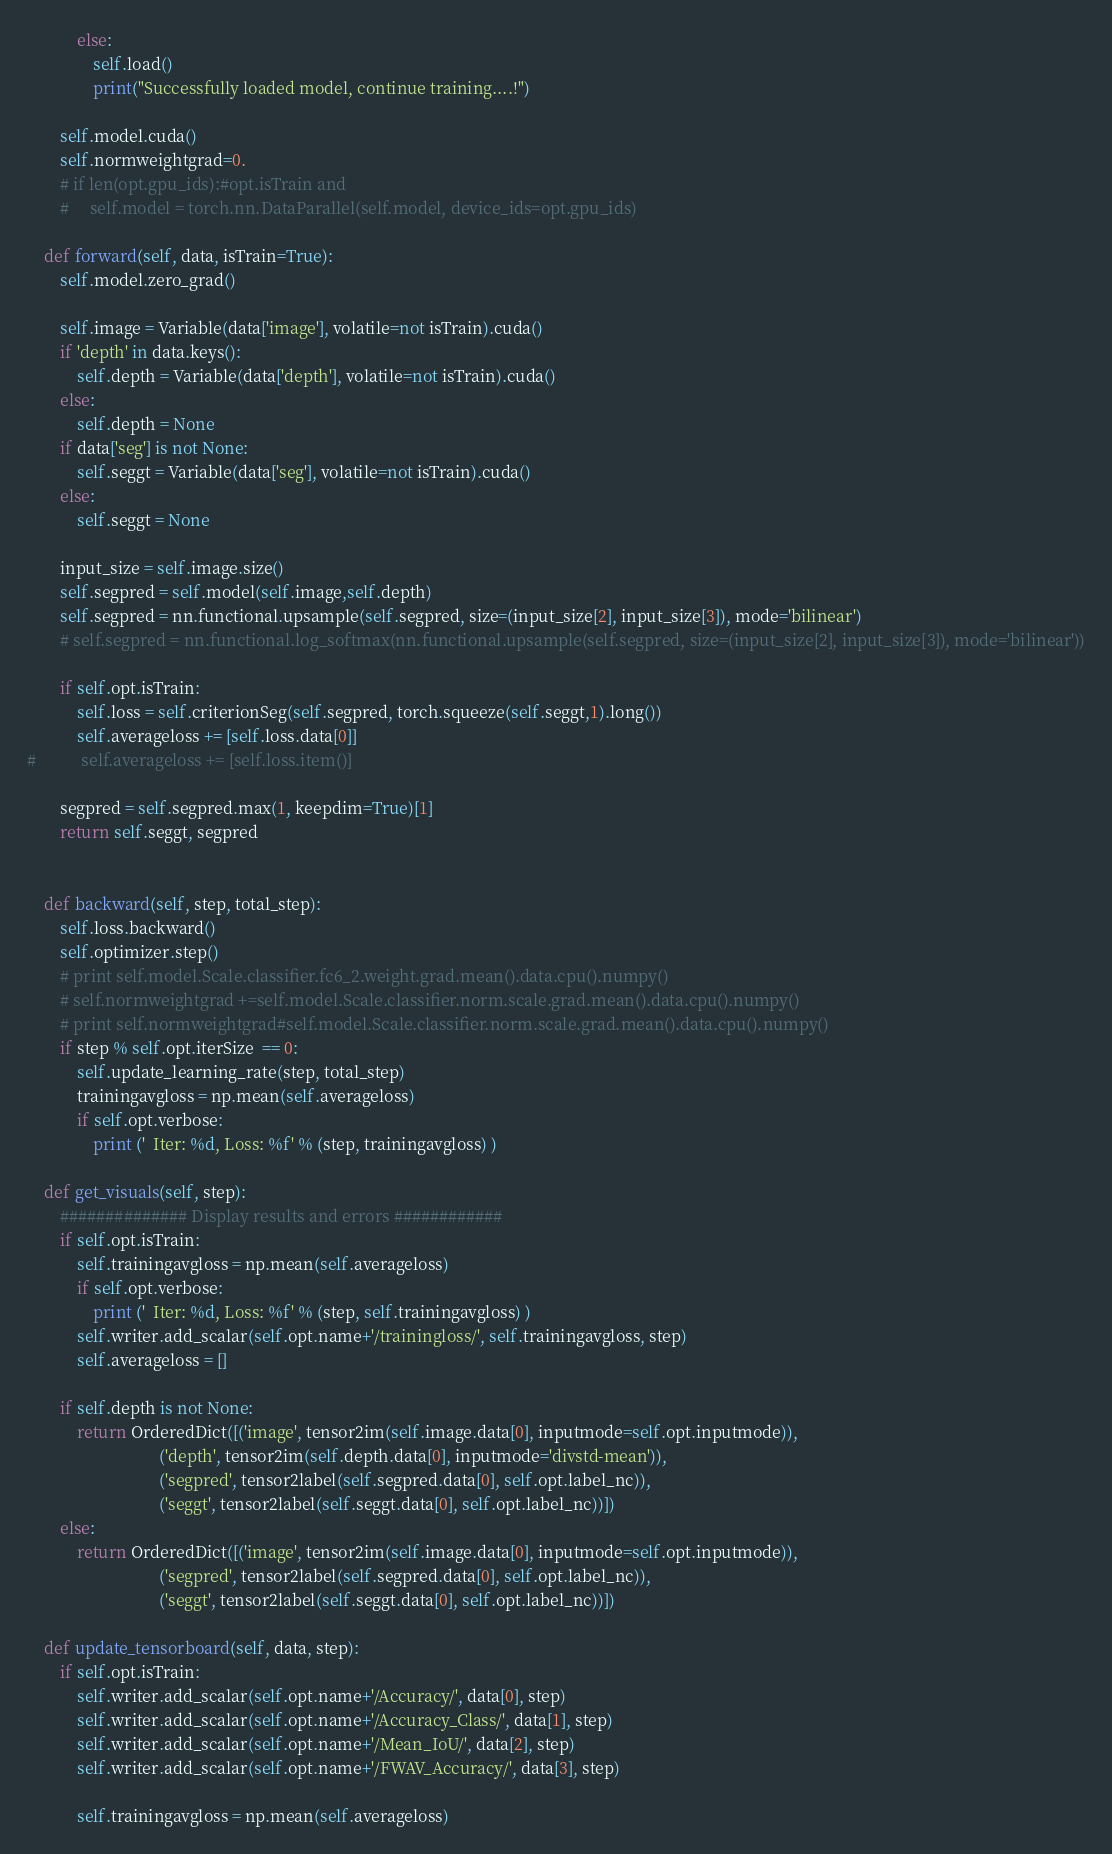<code> <loc_0><loc_0><loc_500><loc_500><_Python_>            else:
                self.load()
                print("Successfully loaded model, continue training....!")

        self.model.cuda()
        self.normweightgrad=0.
        # if len(opt.gpu_ids):#opt.isTrain and
        #     self.model = torch.nn.DataParallel(self.model, device_ids=opt.gpu_ids)

    def forward(self, data, isTrain=True):
        self.model.zero_grad()

        self.image = Variable(data['image'], volatile=not isTrain).cuda()
        if 'depth' in data.keys():
            self.depth = Variable(data['depth'], volatile=not isTrain).cuda()
        else:
            self.depth = None
        if data['seg'] is not None:
            self.seggt = Variable(data['seg'], volatile=not isTrain).cuda()
        else:
            self.seggt = None

        input_size = self.image.size()
        self.segpred = self.model(self.image,self.depth)
        self.segpred = nn.functional.upsample(self.segpred, size=(input_size[2], input_size[3]), mode='bilinear')
        # self.segpred = nn.functional.log_softmax(nn.functional.upsample(self.segpred, size=(input_size[2], input_size[3]), mode='bilinear'))

        if self.opt.isTrain:
            self.loss = self.criterionSeg(self.segpred, torch.squeeze(self.seggt,1).long())
            self.averageloss += [self.loss.data[0]]
#           self.averageloss += [self.loss.item()]
        
        segpred = self.segpred.max(1, keepdim=True)[1]
        return self.seggt, segpred


    def backward(self, step, total_step):
        self.loss.backward()
        self.optimizer.step()
        # print self.model.Scale.classifier.fc6_2.weight.grad.mean().data.cpu().numpy()
        # self.normweightgrad +=self.model.Scale.classifier.norm.scale.grad.mean().data.cpu().numpy()
        # print self.normweightgrad#self.model.Scale.classifier.norm.scale.grad.mean().data.cpu().numpy()
        if step % self.opt.iterSize  == 0:
            self.update_learning_rate(step, total_step)
            trainingavgloss = np.mean(self.averageloss)
            if self.opt.verbose:
                print ('  Iter: %d, Loss: %f' % (step, trainingavgloss) )

    def get_visuals(self, step):
        ############## Display results and errors ############
        if self.opt.isTrain:
            self.trainingavgloss = np.mean(self.averageloss)
            if self.opt.verbose:
                print ('  Iter: %d, Loss: %f' % (step, self.trainingavgloss) )
            self.writer.add_scalar(self.opt.name+'/trainingloss/', self.trainingavgloss, step)
            self.averageloss = []

        if self.depth is not None:
            return OrderedDict([('image', tensor2im(self.image.data[0], inputmode=self.opt.inputmode)),
                                ('depth', tensor2im(self.depth.data[0], inputmode='divstd-mean')),
                                ('segpred', tensor2label(self.segpred.data[0], self.opt.label_nc)),
                                ('seggt', tensor2label(self.seggt.data[0], self.opt.label_nc))])
        else:
            return OrderedDict([('image', tensor2im(self.image.data[0], inputmode=self.opt.inputmode)),
                                ('segpred', tensor2label(self.segpred.data[0], self.opt.label_nc)),
                                ('seggt', tensor2label(self.seggt.data[0], self.opt.label_nc))])

    def update_tensorboard(self, data, step):
        if self.opt.isTrain:
            self.writer.add_scalar(self.opt.name+'/Accuracy/', data[0], step)
            self.writer.add_scalar(self.opt.name+'/Accuracy_Class/', data[1], step)
            self.writer.add_scalar(self.opt.name+'/Mean_IoU/', data[2], step)
            self.writer.add_scalar(self.opt.name+'/FWAV_Accuracy/', data[3], step)

            self.trainingavgloss = np.mean(self.averageloss)</code> 